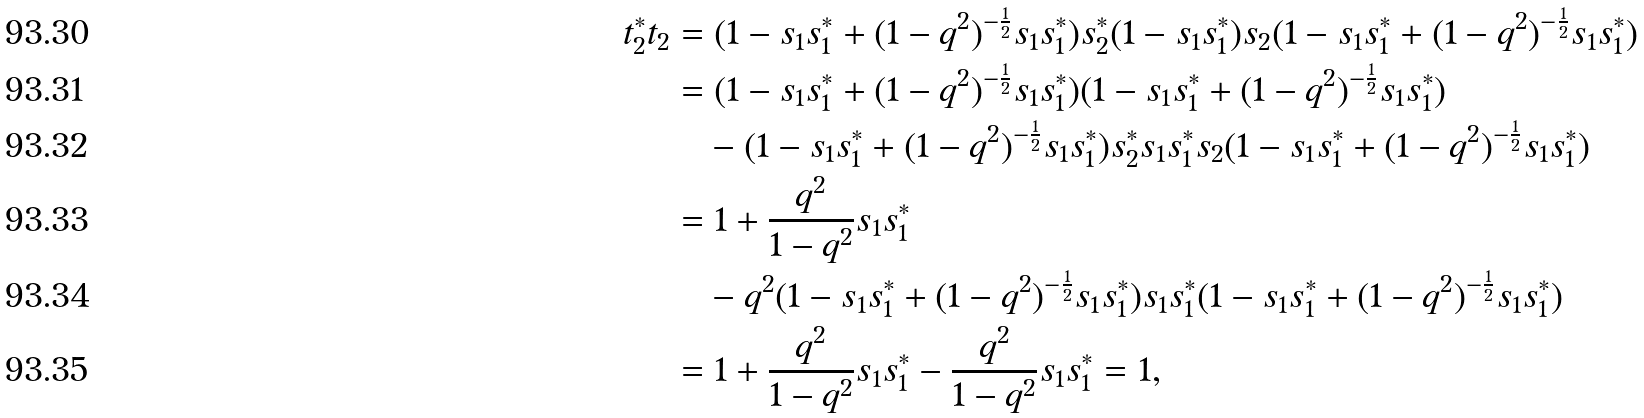Convert formula to latex. <formula><loc_0><loc_0><loc_500><loc_500>t _ { 2 } ^ { * } t _ { 2 } & = ( 1 - s _ { 1 } s _ { 1 } ^ { * } + ( 1 - q ^ { 2 } ) ^ { - \frac { 1 } { 2 } } s _ { 1 } s _ { 1 } ^ { * } ) s _ { 2 } ^ { * } ( 1 - s _ { 1 } s _ { 1 } ^ { * } ) s _ { 2 } ( 1 - s _ { 1 } s _ { 1 } ^ { * } + ( 1 - q ^ { 2 } ) ^ { - \frac { 1 } { 2 } } s _ { 1 } s _ { 1 } ^ { * } ) \\ & = ( 1 - s _ { 1 } s _ { 1 } ^ { * } + ( 1 - q ^ { 2 } ) ^ { - \frac { 1 } { 2 } } s _ { 1 } s _ { 1 } ^ { * } ) ( 1 - s _ { 1 } s _ { 1 } ^ { * } + ( 1 - q ^ { 2 } ) ^ { - \frac { 1 } { 2 } } s _ { 1 } s _ { 1 } ^ { * } ) \\ & \quad - ( 1 - s _ { 1 } s _ { 1 } ^ { * } + ( 1 - q ^ { 2 } ) ^ { - \frac { 1 } { 2 } } s _ { 1 } s _ { 1 } ^ { * } ) s _ { 2 } ^ { * } s _ { 1 } s _ { 1 } ^ { * } s _ { 2 } ( 1 - s _ { 1 } s _ { 1 } ^ { * } + ( 1 - q ^ { 2 } ) ^ { - \frac { 1 } { 2 } } s _ { 1 } s _ { 1 } ^ { * } ) \\ & = 1 + \frac { q ^ { 2 } } { 1 - q ^ { 2 } } s _ { 1 } s _ { 1 } ^ { * } \\ & \quad - q ^ { 2 } ( 1 - s _ { 1 } s _ { 1 } ^ { * } + ( 1 - q ^ { 2 } ) ^ { - \frac { 1 } { 2 } } s _ { 1 } s _ { 1 } ^ { * } ) s _ { 1 } s _ { 1 } ^ { * } ( 1 - s _ { 1 } s _ { 1 } ^ { * } + ( 1 - q ^ { 2 } ) ^ { - \frac { 1 } { 2 } } s _ { 1 } s _ { 1 } ^ { * } ) \\ & = 1 + \frac { q ^ { 2 } } { 1 - q ^ { 2 } } s _ { 1 } s _ { 1 } ^ { * } - \frac { q ^ { 2 } } { 1 - q ^ { 2 } } s _ { 1 } s _ { 1 } ^ { * } = 1 ,</formula> 